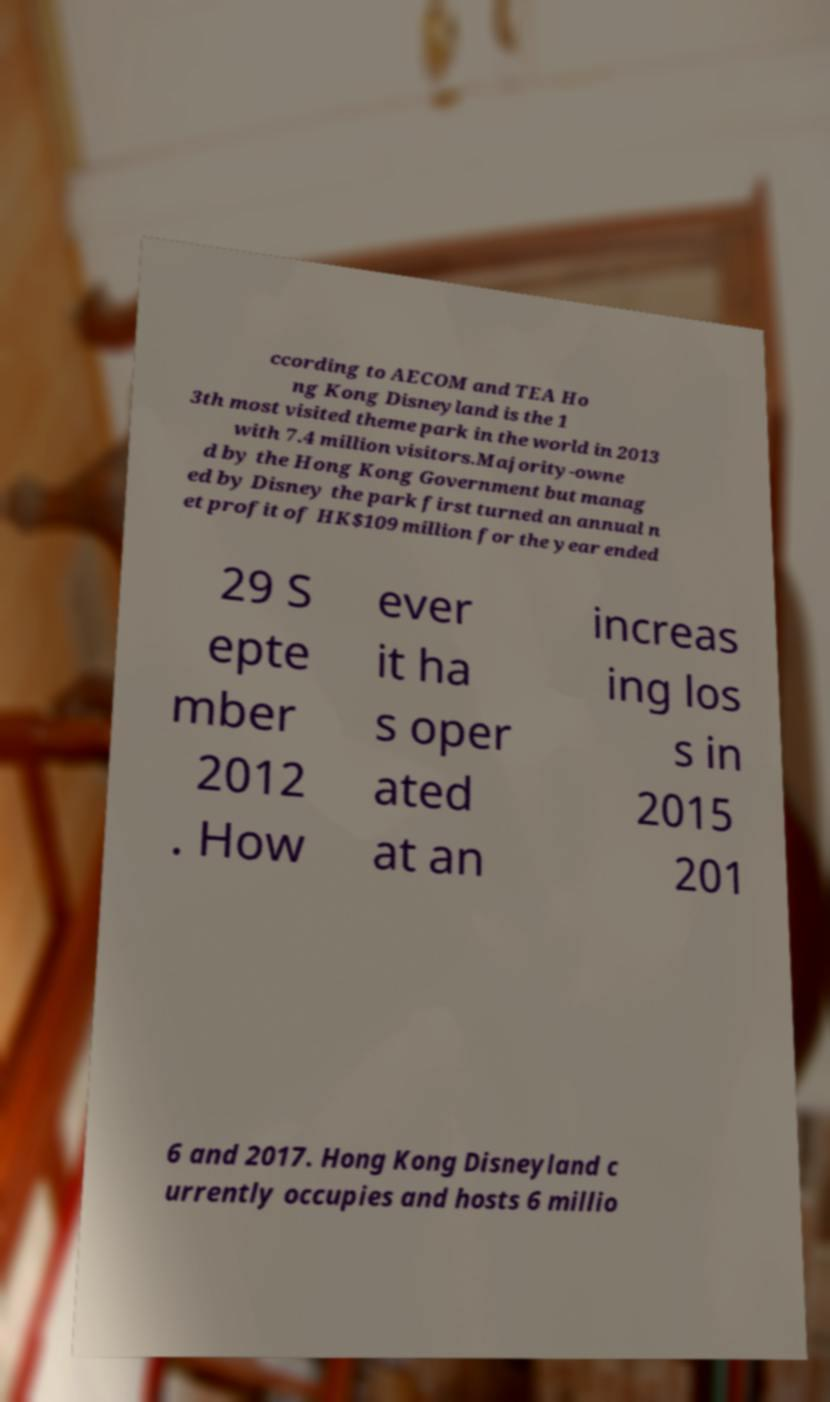Could you assist in decoding the text presented in this image and type it out clearly? ccording to AECOM and TEA Ho ng Kong Disneyland is the 1 3th most visited theme park in the world in 2013 with 7.4 million visitors.Majority-owne d by the Hong Kong Government but manag ed by Disney the park first turned an annual n et profit of HK$109 million for the year ended 29 S epte mber 2012 . How ever it ha s oper ated at an increas ing los s in 2015 201 6 and 2017. Hong Kong Disneyland c urrently occupies and hosts 6 millio 